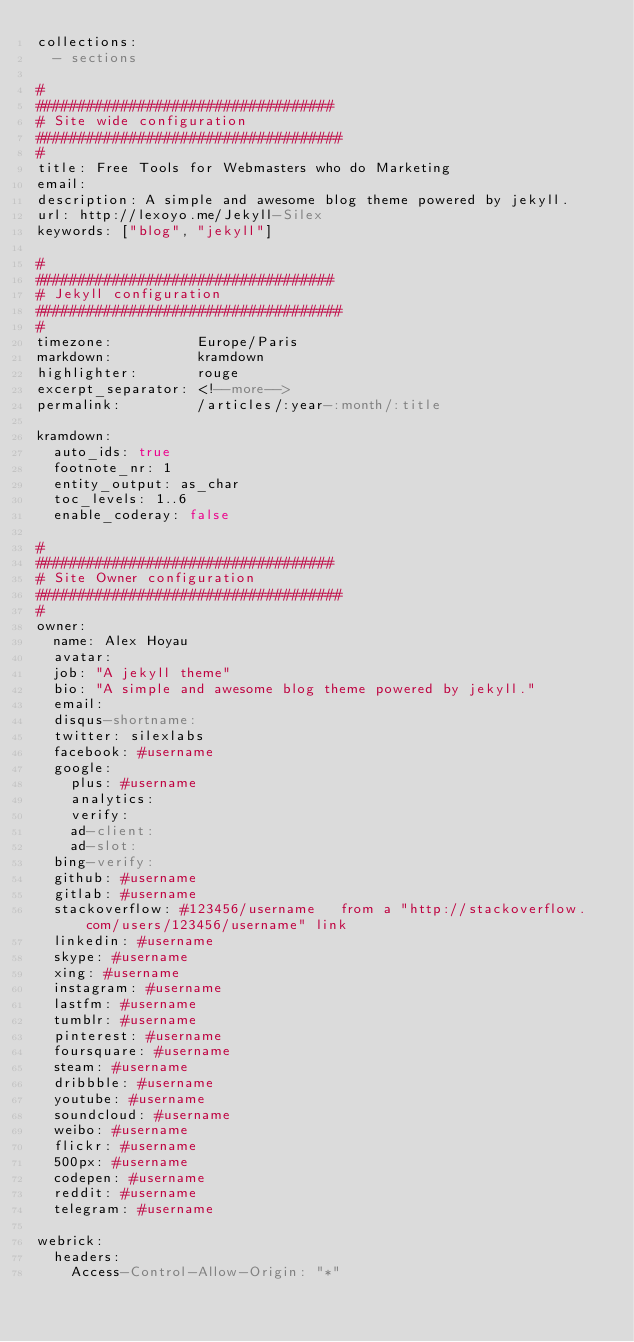<code> <loc_0><loc_0><loc_500><loc_500><_YAML_>collections:
  - sections

#
###################################
# Site wide configuration
####################################
#
title: Free Tools for Webmasters who do Marketing
email:
description: A simple and awesome blog theme powered by jekyll.
url: http://lexoyo.me/Jekyll-Silex
keywords: ["blog", "jekyll"]

#
###################################
# Jekyll configuration
####################################
#
timezone:          Europe/Paris
markdown:          kramdown
highlighter:       rouge
excerpt_separator: <!--more-->
permalink:         /articles/:year-:month/:title

kramdown:
  auto_ids: true
  footnote_nr: 1
  entity_output: as_char
  toc_levels: 1..6
  enable_coderay: false

#
###################################
# Site Owner configuration
####################################
#
owner:
  name: Alex Hoyau
  avatar: 
  job: "A jekyll theme"
  bio: "A simple and awesome blog theme powered by jekyll."
  email:
  disqus-shortname:
  twitter: silexlabs
  facebook: #username
  google:
    plus: #username
    analytics:
    verify:
    ad-client:
    ad-slot:
  bing-verify:
  github: #username
  gitlab: #username
  stackoverflow: #123456/username   from a "http://stackoverflow.com/users/123456/username" link
  linkedin: #username
  skype: #username
  xing: #username
  instagram: #username
  lastfm: #username
  tumblr: #username
  pinterest: #username
  foursquare: #username
  steam: #username
  dribbble: #username
  youtube: #username
  soundcloud: #username
  weibo: #username
  flickr: #username
  500px: #username
  codepen: #username
  reddit: #username
  telegram: #username

webrick:
  headers:
    Access-Control-Allow-Origin: "*"
</code> 